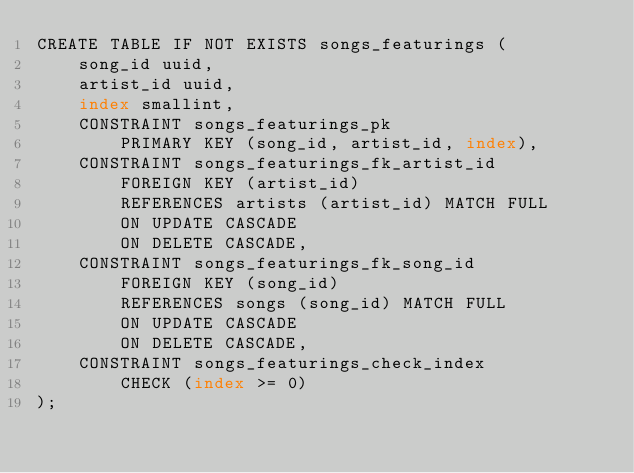Convert code to text. <code><loc_0><loc_0><loc_500><loc_500><_SQL_>CREATE TABLE IF NOT EXISTS songs_featurings (
	song_id uuid,
	artist_id uuid,
	index smallint,
	CONSTRAINT songs_featurings_pk
		PRIMARY KEY (song_id, artist_id, index),
	CONSTRAINT songs_featurings_fk_artist_id
		FOREIGN KEY (artist_id)
		REFERENCES artists (artist_id) MATCH FULL
		ON UPDATE CASCADE
		ON DELETE CASCADE,
	CONSTRAINT songs_featurings_fk_song_id
		FOREIGN KEY (song_id)
		REFERENCES songs (song_id) MATCH FULL
		ON UPDATE CASCADE
		ON DELETE CASCADE,
	CONSTRAINT songs_featurings_check_index
		CHECK (index >= 0)
);</code> 